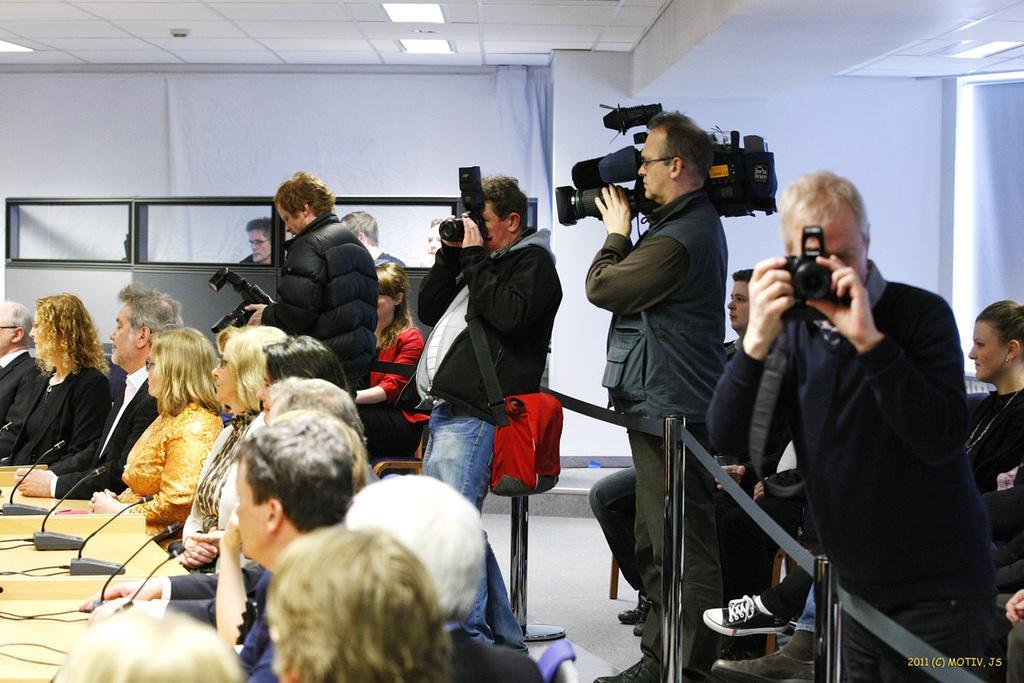How would you summarize this image in a sentence or two? In this we can see some group of persons sitting on chairs around the table there are some microphones on it, on the right side of the image there are some cameraman who are holding cameras in their hands some are sitting and some are standing and in the background of the image there is a wall. 